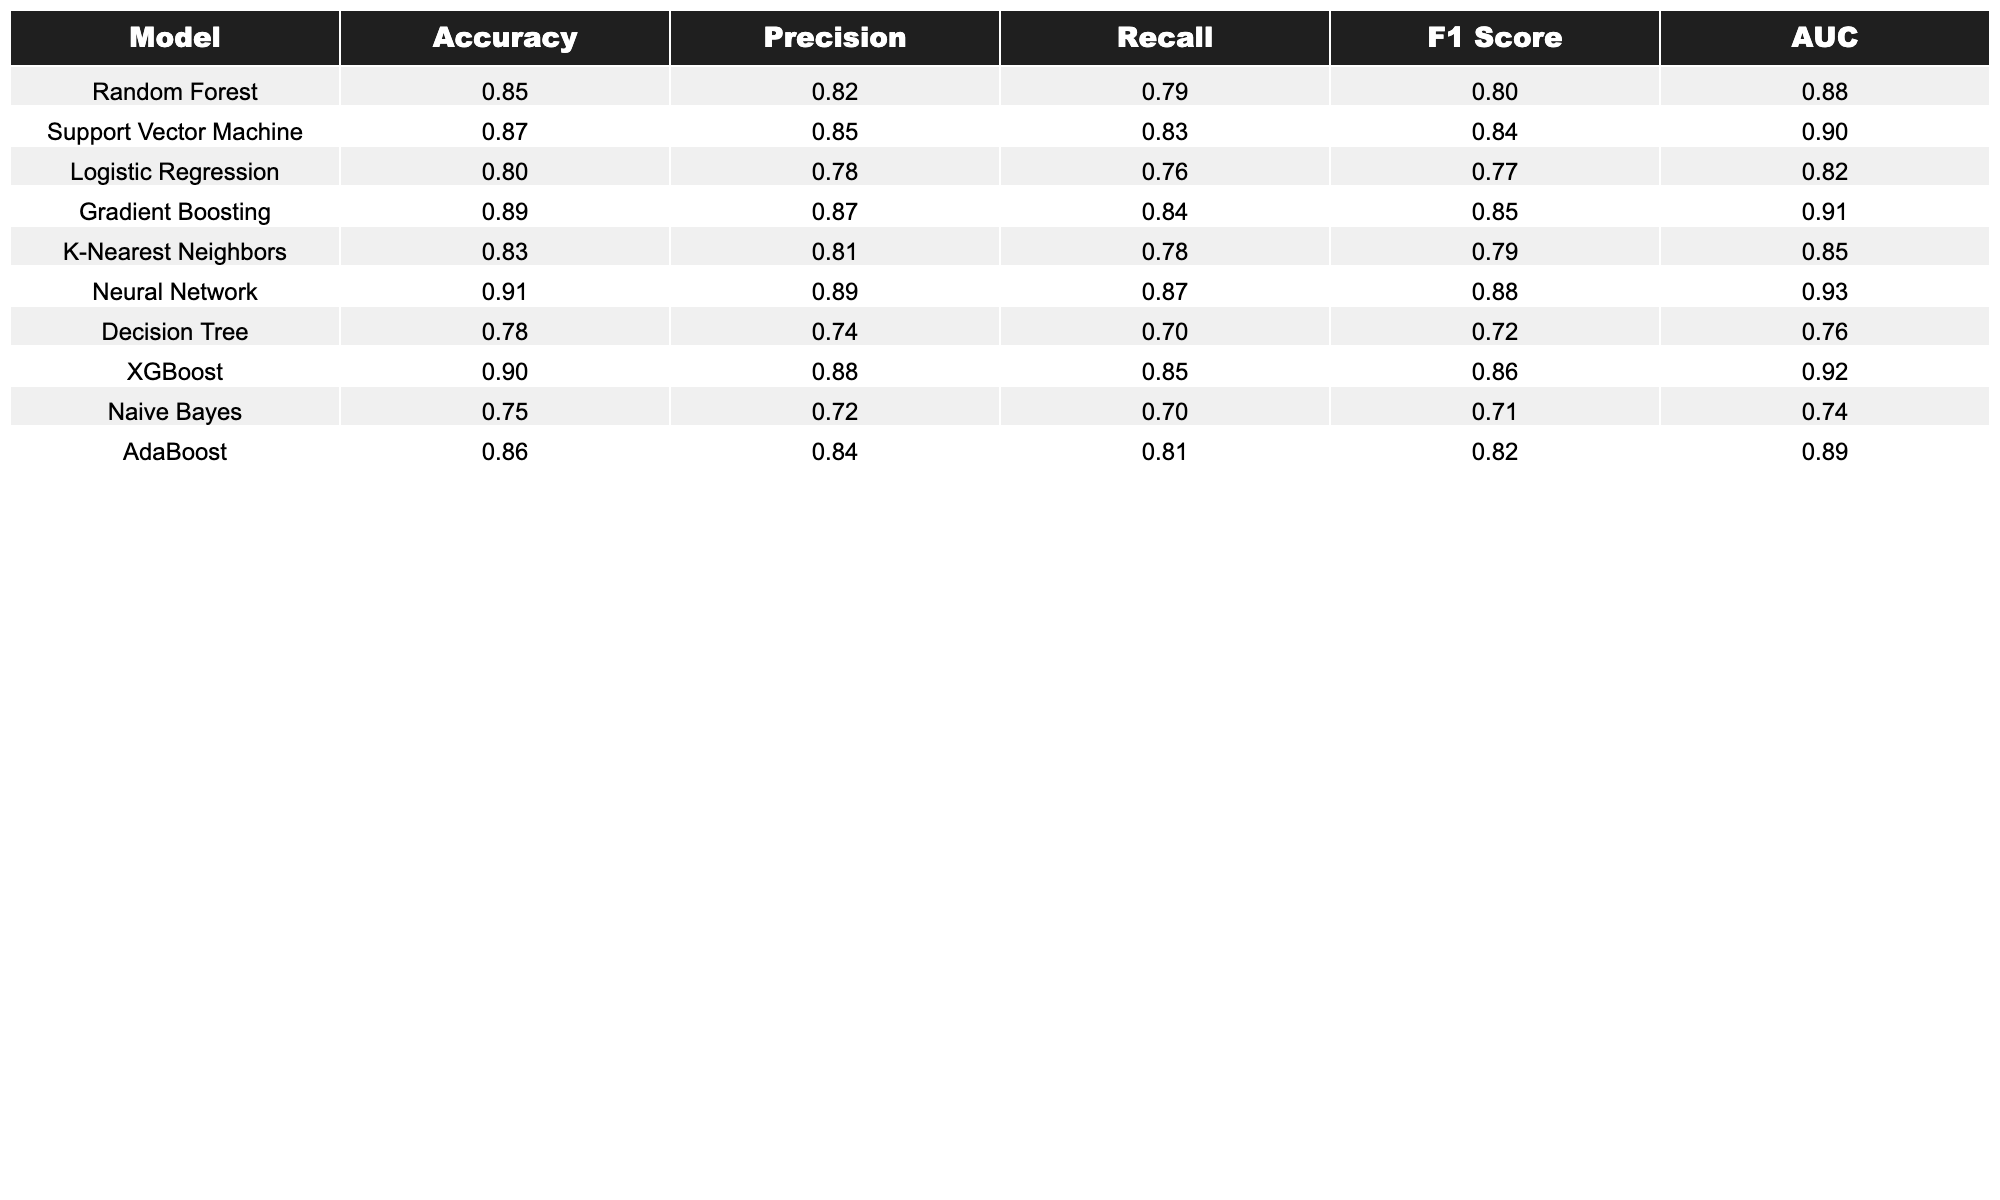What is the Accuracy of the Neural Network model? The table shows the performance metrics for each model. For the Neural Network, the Accuracy is listed as 0.91.
Answer: 0.91 Which model has the highest F1 Score? By examining the F1 Score values in the table, the Neural Network has the highest score at 0.88, compared to all other models.
Answer: Neural Network What are the Precision and Recall for the Gradient Boosting model? The table provides values for Precision and Recall under the Gradient Boosting row, which are 0.87 and 0.84, respectively.
Answer: Precision: 0.87, Recall: 0.84 Is the AUC for the Support Vector Machine greater than 0.89? Looking at the AUC value for the Support Vector Machine in the table, which is 0.90, we can conclude that it is indeed greater than 0.89.
Answer: Yes What is the difference in Accuracy between the Random Forest and the Decision Tree models? The Accuracy for Random Forest is 0.85 and for Decision Tree is 0.78. Thus, the difference is 0.85 - 0.78 = 0.07.
Answer: 0.07 Calculate the average Precision of all models. To find the average Precision, sum the Precision values (0.82 + 0.85 + 0.78 + 0.87 + 0.81 + 0.89 + 0.74 + 0.88 + 0.72 + 0.84) which equals 8.81, then divide by the number of models (10): 8.81/10 = 0.881.
Answer: 0.881 Which model has the lowest Recall? By checking the Recall values in the table, the Decision Tree has the lowest Recall score of 0.70 compared to the others.
Answer: Decision Tree Are the AUC scores for XGBoost and Neural Network both above 0.90? The AUC for XGBoost is 0.92 and for Neural Network is 0.93, thus both scores are above 0.90.
Answer: Yes If we rank the models by Accuracy, what is the third model? Analyzing the Accuracy values in descending order gives Neural Network (0.91), XGBoost (0.90), and Gradient Boosting (0.89) as the third model.
Answer: Gradient Boosting What is the total of the F1 Scores for all models? Adding the F1 Scores of all models: (0.80 + 0.84 + 0.77 + 0.85 + 0.79 + 0.88 + 0.72 + 0.86 + 0.71 + 0.82) gives a total of 8.14.
Answer: 8.14 